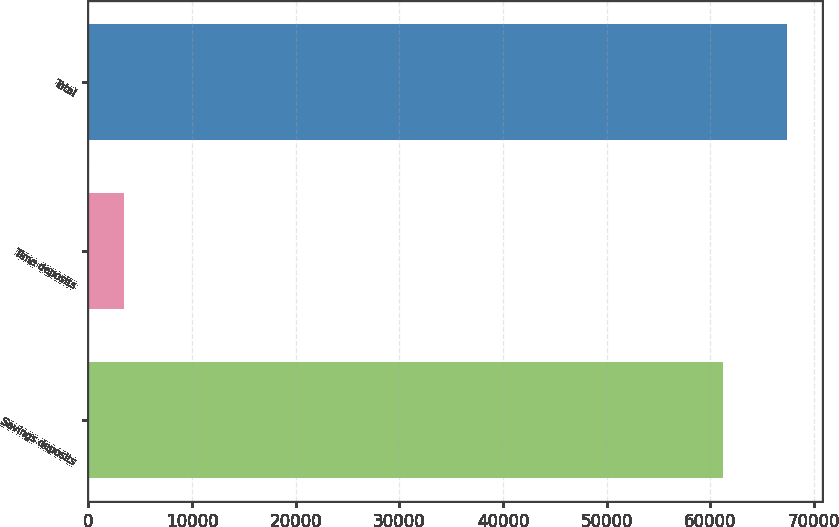Convert chart to OTSL. <chart><loc_0><loc_0><loc_500><loc_500><bar_chart><fcel>Savings deposits<fcel>Time deposits<fcel>Total<nl><fcel>61258<fcel>3392<fcel>67383.8<nl></chart> 